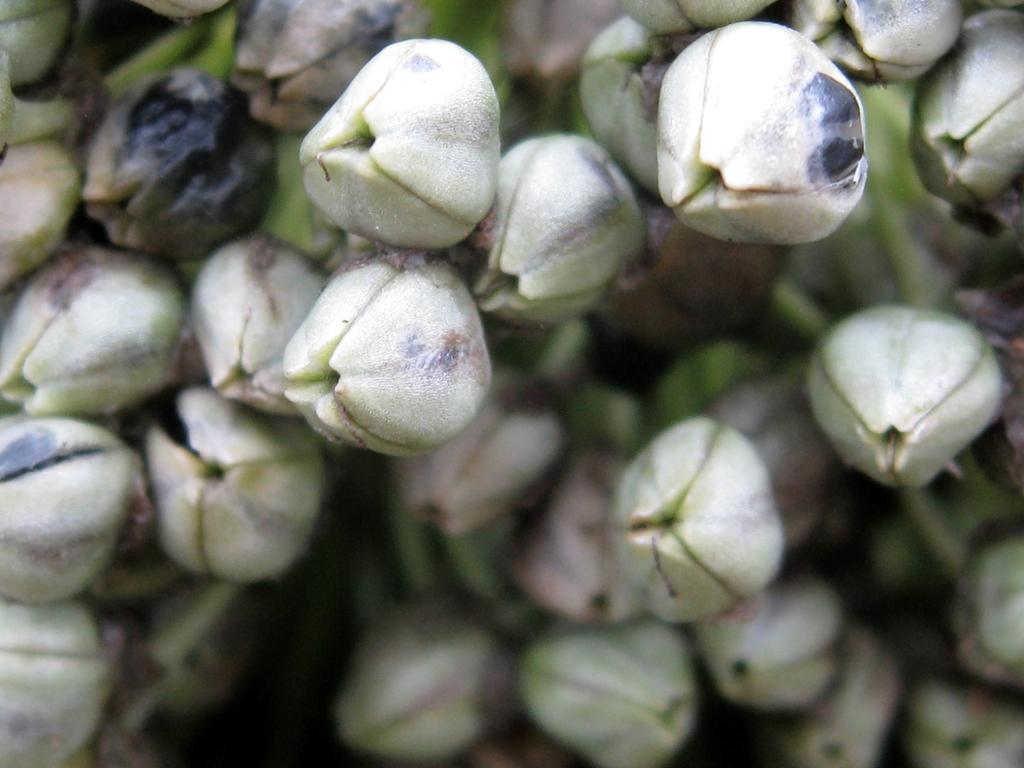What type of plant life is visible in the image? There are flower buds in the image. What credit card company is sponsoring the flower buds in the image? There is no credit card company mentioned or implied in the image, as it only features flower buds. 